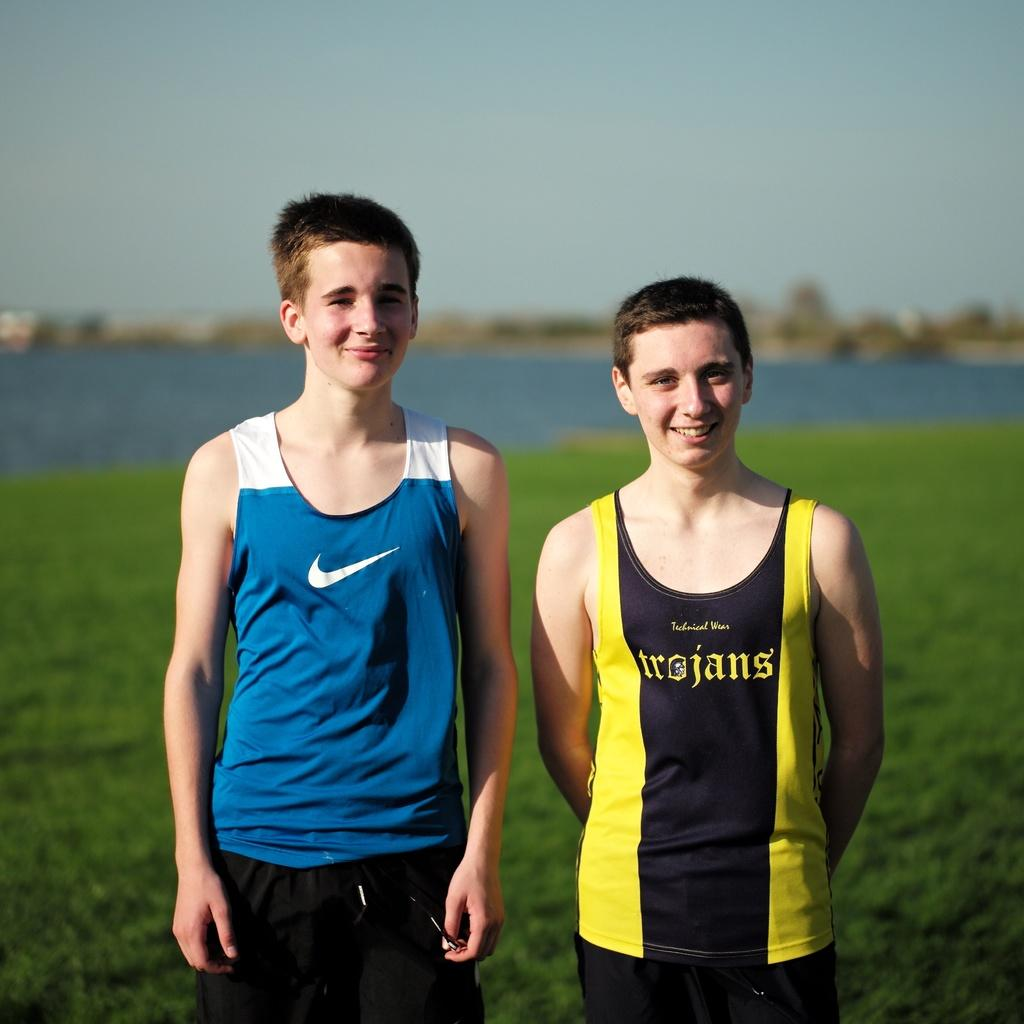<image>
Share a concise interpretation of the image provided. the name trojans that is on a person's jersey 